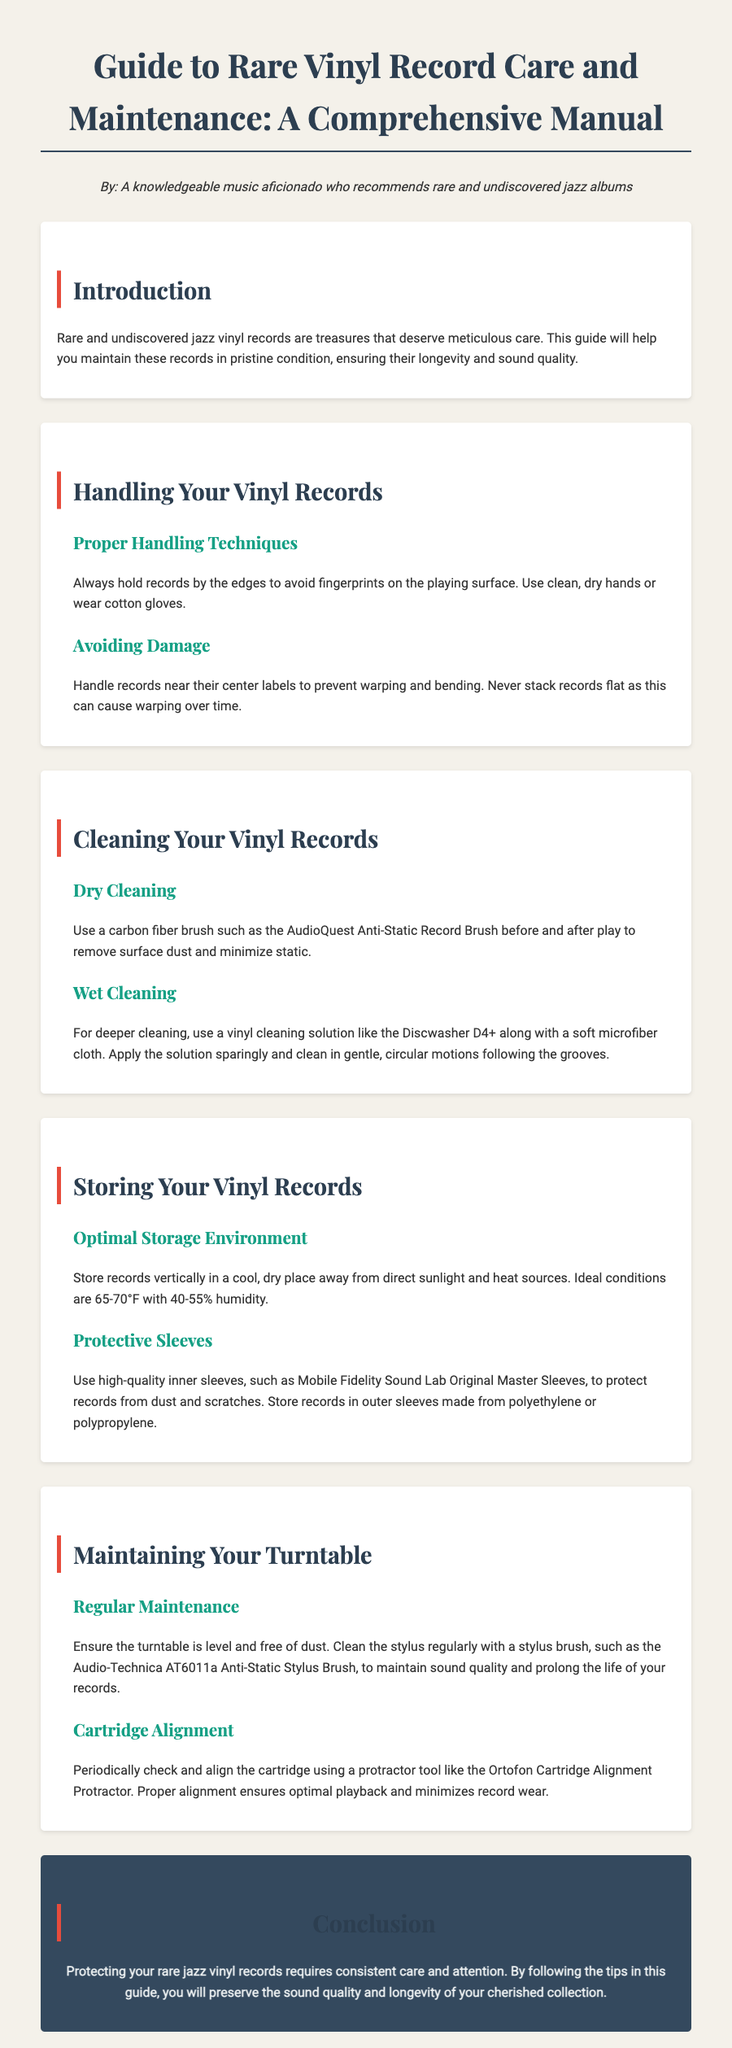What is the optimal storage environment temperature for vinyl records? The document specifies that the ideal temperature conditions for storing records are 65-70°F.
Answer: 65-70°F What type of brush should be used for dry cleaning? The guide recommends using a carbon fiber brush like the AudioQuest Anti-Static Record Brush for dry cleaning.
Answer: AudioQuest Anti-Static Record Brush How should records be handled to avoid fingerprints? Records should be held by the edges to avoid fingerprints on the playing surface.
Answer: By the edges What is the recommended humidity range for storing vinyl records? The document states that the ideal humidity for storing records is 40-55%.
Answer: 40-55% What is one type of protective sleeve suggested for vinyl records? The guide suggests using high-quality inner sleeves such as Mobile Fidelity Sound Lab Original Master Sleeves.
Answer: Mobile Fidelity Sound Lab Original Master Sleeves What should be checked to ensure optimal playback? The document mentions that cartridge alignment should be checked regularly to ensure optimal playback.
Answer: Cartridge alignment How often should the stylus be cleaned? The guide advises cleaning the stylus regularly to maintain sound quality and prolong the life of records.
Answer: Regularly What cleaning solution is recommended for deeper cleaning? The document recommends using the Discwasher D4+ for deeper cleaning of vinyl records.
Answer: Discwasher D4+ What is a recommended method to minimize static before playing records? The guide suggests using a carbon fiber brush before and after play to minimize static.
Answer: Carbon fiber brush 